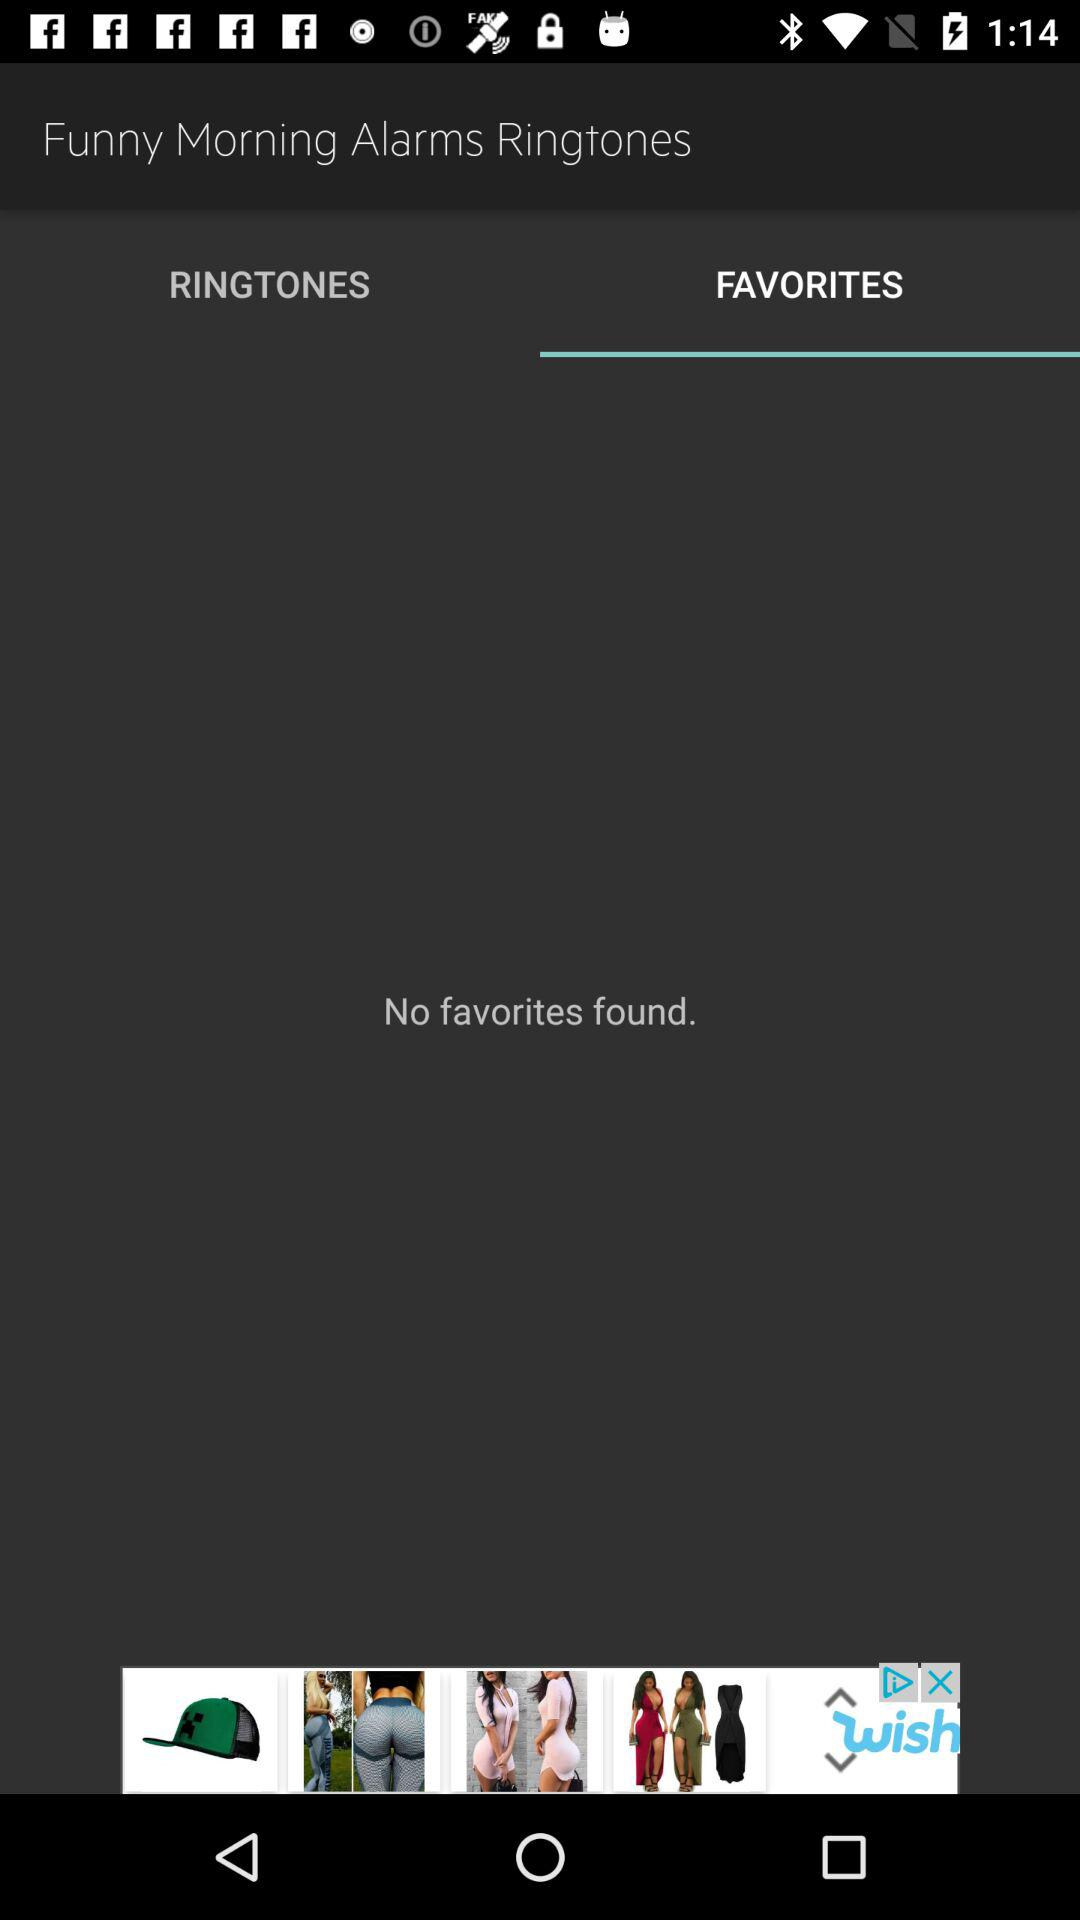Which alarm ringtone category am I in? You are in the "Favorites" category. 